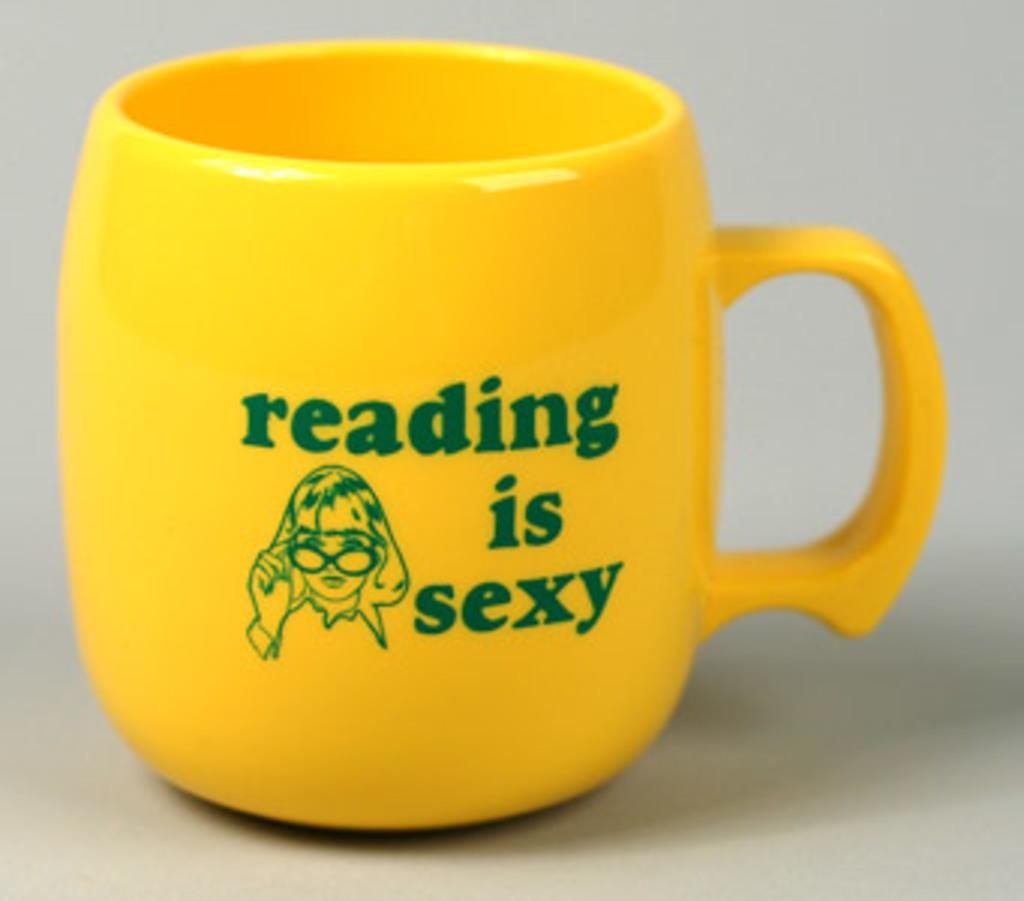<image>
Present a compact description of the photo's key features. A yellowmug has the words reading is sexy on it. 